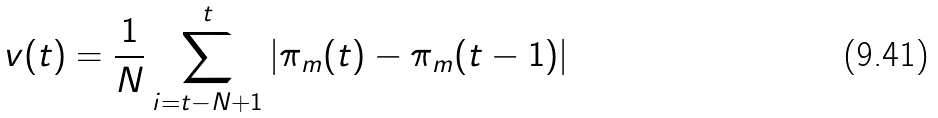<formula> <loc_0><loc_0><loc_500><loc_500>v ( t ) = \frac { 1 } { N } \sum _ { i = t - N + 1 } ^ { t } | \pi _ { m } ( t ) - \pi _ { m } ( t - 1 ) |</formula> 